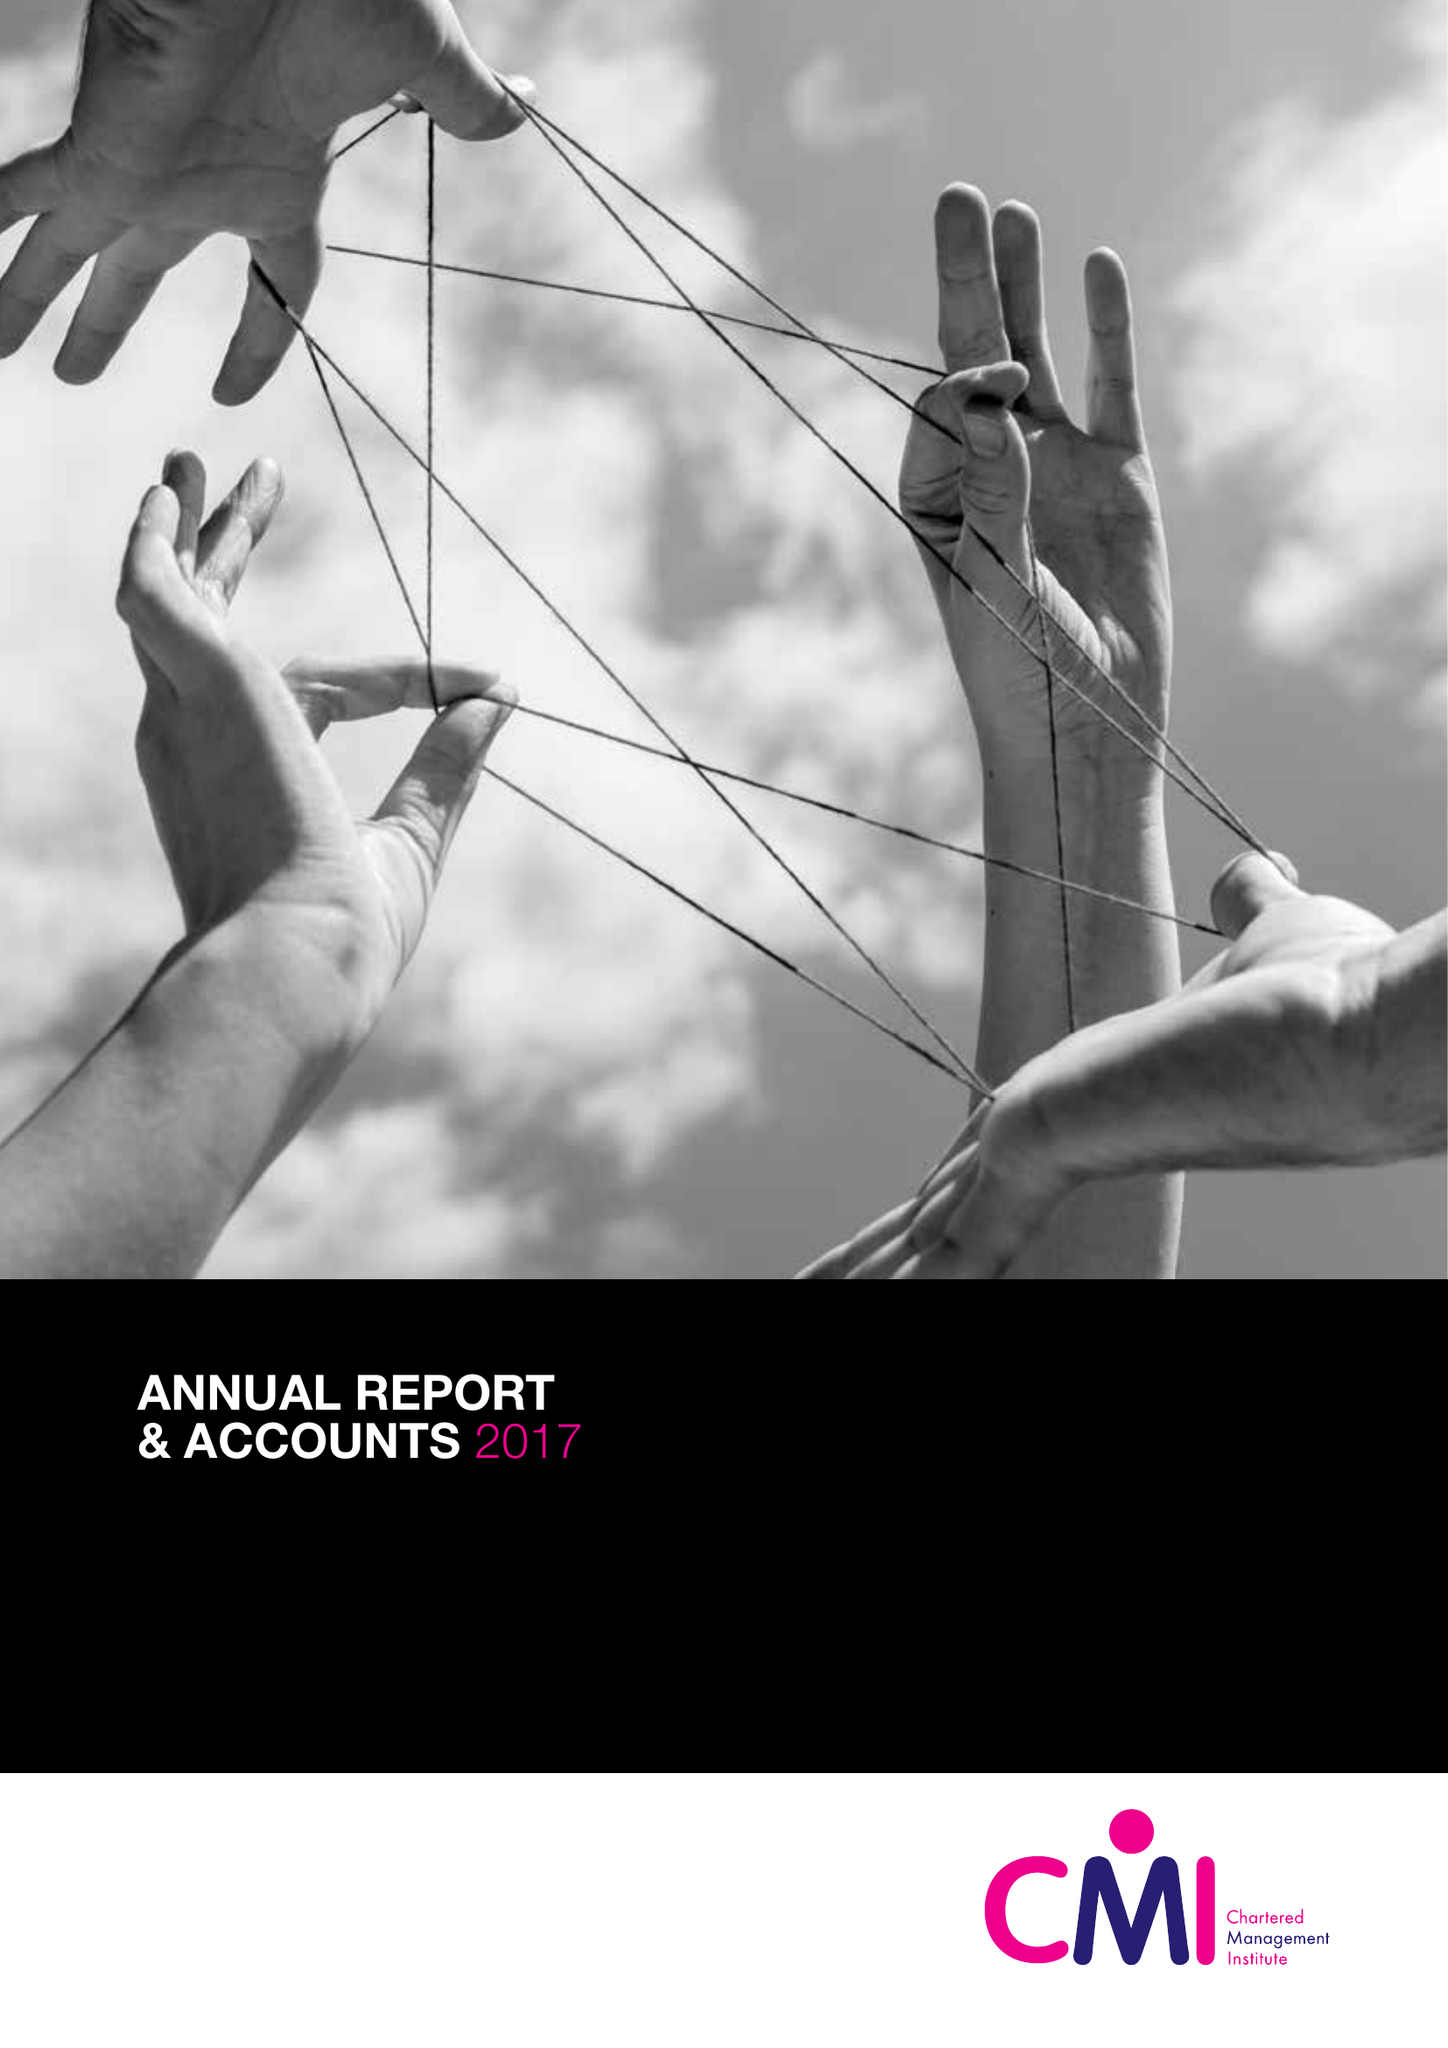What is the value for the charity_name?
Answer the question using a single word or phrase. Chartered Management Institute 